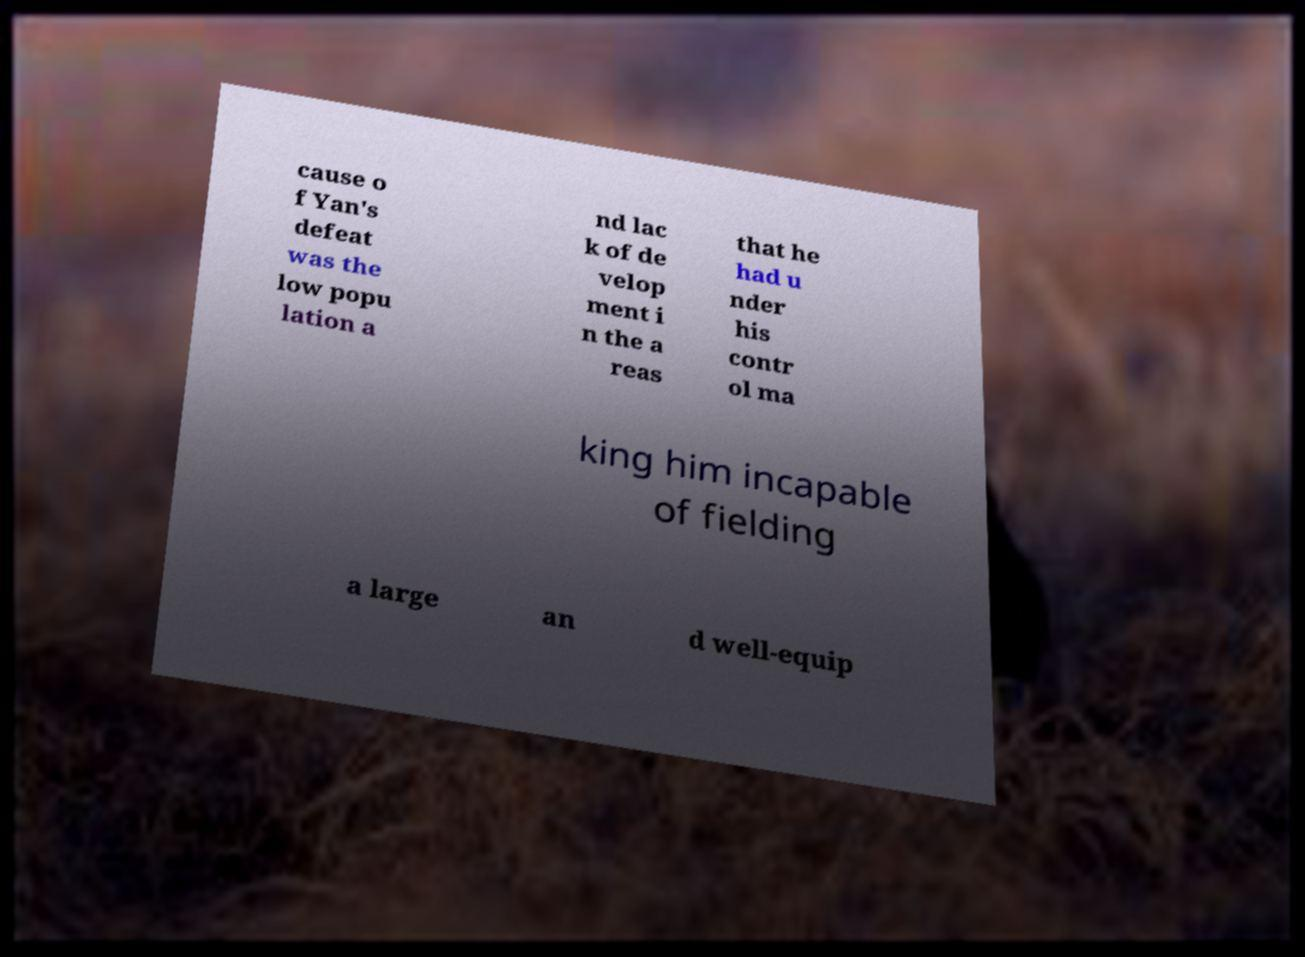For documentation purposes, I need the text within this image transcribed. Could you provide that? cause o f Yan's defeat was the low popu lation a nd lac k of de velop ment i n the a reas that he had u nder his contr ol ma king him incapable of fielding a large an d well-equip 